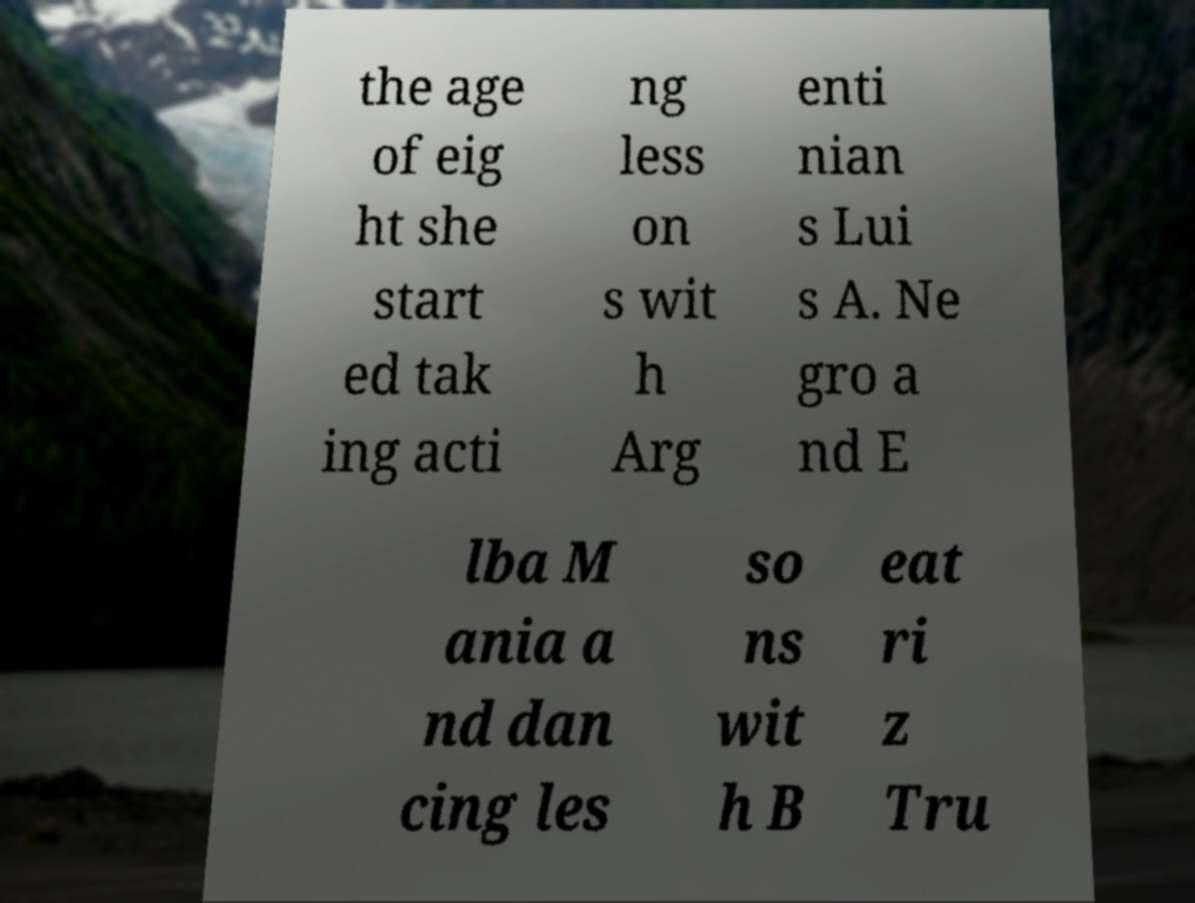Please identify and transcribe the text found in this image. the age of eig ht she start ed tak ing acti ng less on s wit h Arg enti nian s Lui s A. Ne gro a nd E lba M ania a nd dan cing les so ns wit h B eat ri z Tru 